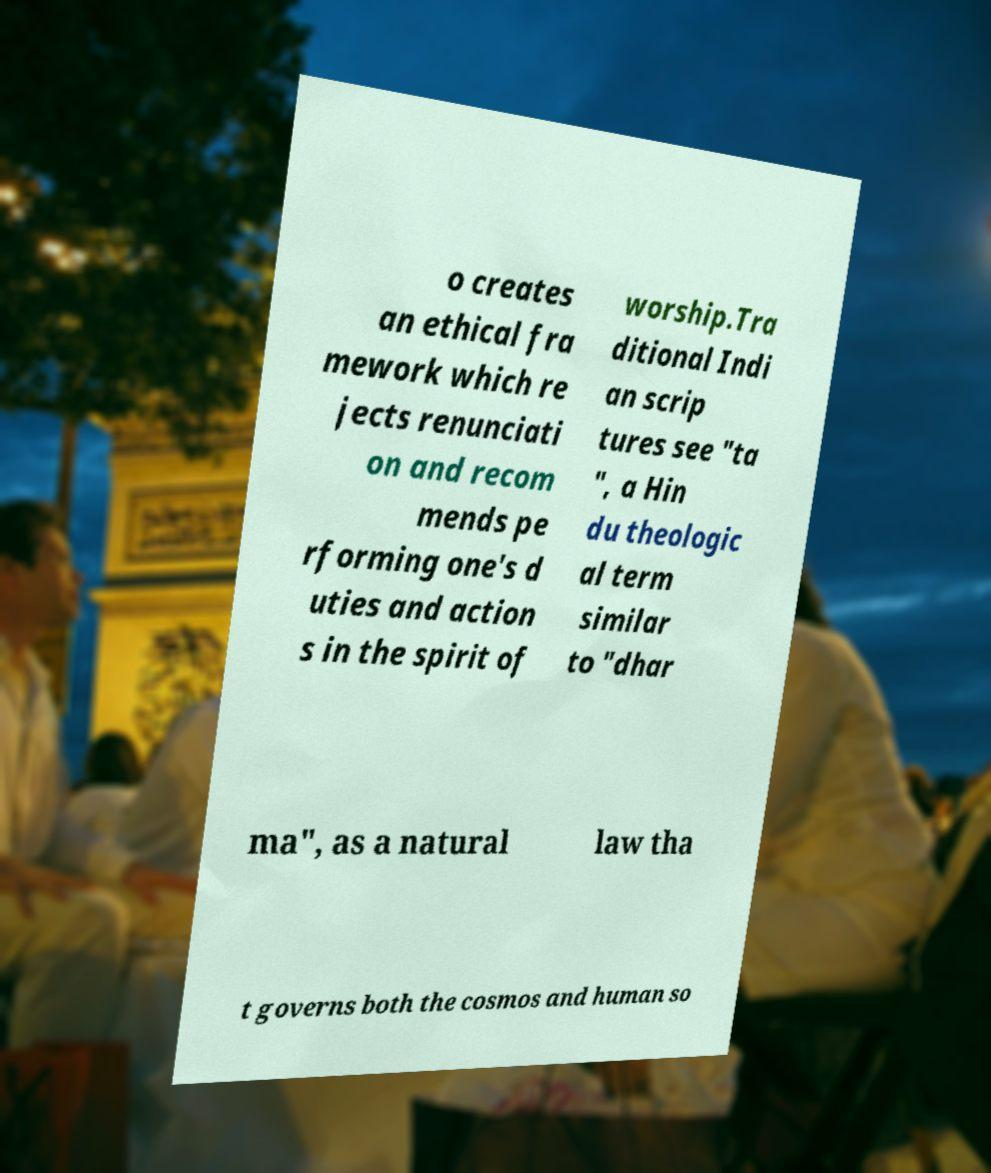Can you accurately transcribe the text from the provided image for me? o creates an ethical fra mework which re jects renunciati on and recom mends pe rforming one's d uties and action s in the spirit of worship.Tra ditional Indi an scrip tures see "ta ", a Hin du theologic al term similar to "dhar ma", as a natural law tha t governs both the cosmos and human so 